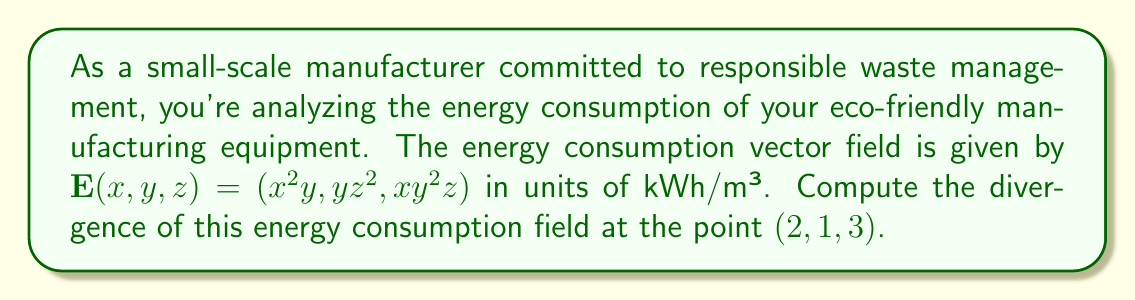Could you help me with this problem? To solve this problem, we'll follow these steps:

1) The divergence of a vector field $\mathbf{E}(x,y,z) = (E_x, E_y, E_z)$ is given by:

   $$\nabla \cdot \mathbf{E} = \frac{\partial E_x}{\partial x} + \frac{\partial E_y}{\partial y} + \frac{\partial E_z}{\partial z}$$

2) For our vector field $\mathbf{E}(x,y,z) = (x^2y, yz^2, xy^2z)$, we have:
   
   $E_x = x^2y$
   $E_y = yz^2$
   $E_z = xy^2z$

3) Let's calculate each partial derivative:

   $\frac{\partial E_x}{\partial x} = 2xy$
   
   $\frac{\partial E_y}{\partial y} = z^2$
   
   $\frac{\partial E_z}{\partial z} = xy^2$

4) Now, we can substitute these into the divergence formula:

   $$\nabla \cdot \mathbf{E} = 2xy + z^2 + xy^2$$

5) To find the divergence at the point $(2,1,3)$, we substitute $x=2$, $y=1$, and $z=3$:

   $$\nabla \cdot \mathbf{E}_{(2,1,3)} = 2(2)(1) + 3^2 + 2(1)^2 = 4 + 9 + 2 = 15$$

Thus, the divergence of the energy consumption field at $(2,1,3)$ is 15 kWh/m³.
Answer: 15 kWh/m³ 